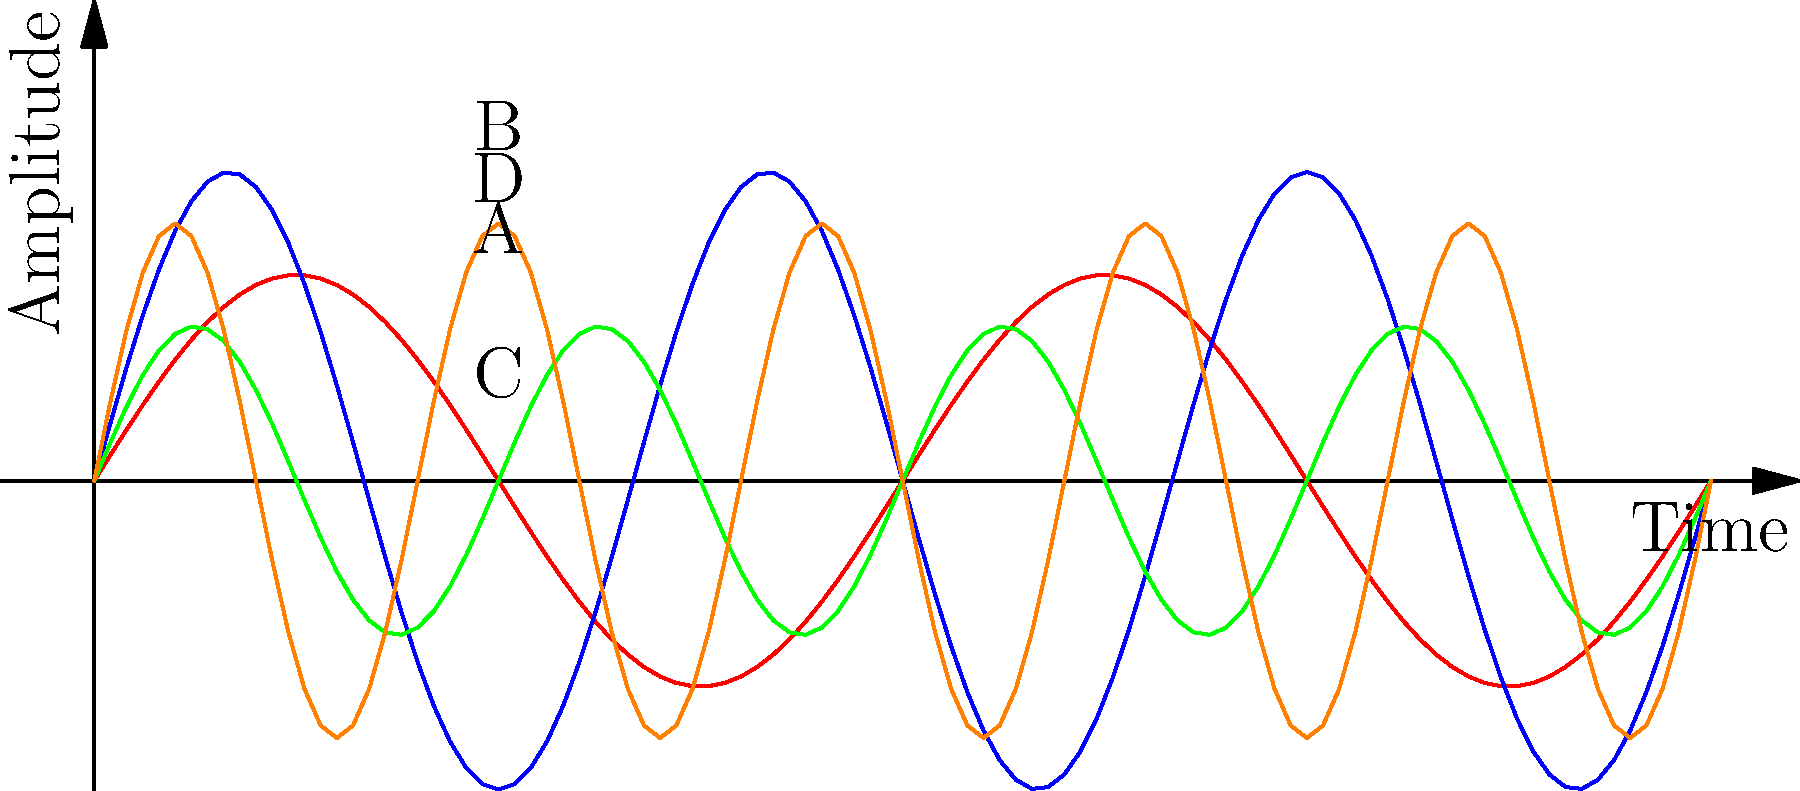Which sound wave pattern likely represents the mellow, dreamlike quality often found in Black Market Karma's psychedelic tracks, such as "The Sky Was All Diseased"? To answer this question, we need to analyze the characteristics of each sound wave and relate them to the musical qualities of Black Market Karma's psychedelic tracks:

1. Wave A (Red): Moderate amplitude and low frequency. This represents a balanced, smooth sound.

2. Wave B (Blue): High amplitude and moderate frequency. This suggests a more intense, possibly energetic sound.

3. Wave C (Green): Low amplitude and high frequency. This indicates a softer, higher-pitched sound.

4. Wave D (Orange): Moderate amplitude and high frequency. This represents a balanced but more intricate sound.

Black Market Karma's psychedelic tracks, particularly "The Sky Was All Diseased," are known for their mellow, dreamlike qualities. In sound wave terms, this would typically be represented by:

- Moderate amplitude: Not too loud or soft, creating a balanced sound.
- Lower frequency: Producing a deeper, more relaxed tone.

Among the given options, Wave A (Red) best fits these characteristics. It has a moderate amplitude, ensuring a balanced sound, and the lowest frequency among all options, which would create the mellow, dreamlike quality characteristic of BMK's psychedelic tracks.
Answer: A (Red) 